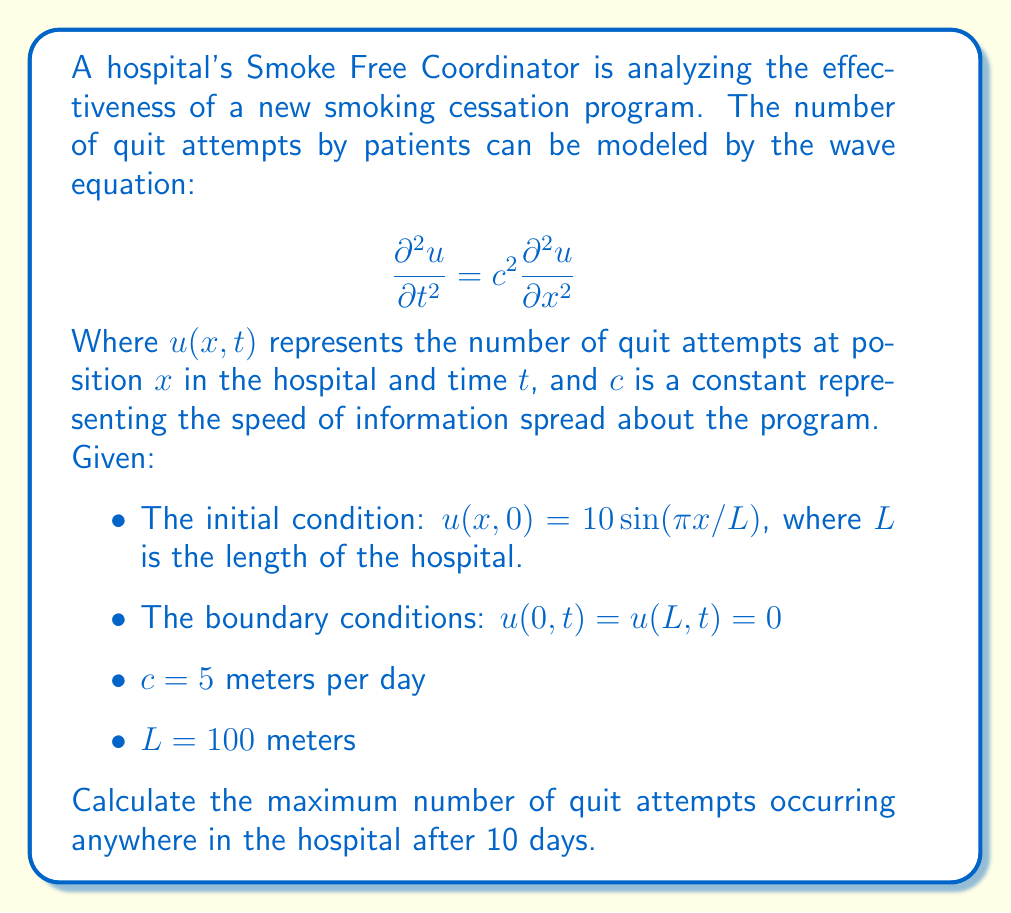Could you help me with this problem? To solve this problem, we need to use the general solution of the wave equation with the given initial and boundary conditions. The solution takes the form:

$$u(x,t) = \sum_{n=1}^{\infty} [A_n \cos(n\pi ct/L) + B_n \sin(n\pi ct/L)] \sin(n\pi x/L)$$

Given the initial condition $u(x,0) = 10 \sin(\pi x/L)$, we can determine that only the first term of the series (n=1) is non-zero, and $A_1 = 10$, $B_1 = 0$. Thus, our solution simplifies to:

$$u(x,t) = 10 \cos(\pi ct/L) \sin(\pi x/L)$$

To find the maximum number of quit attempts after 10 days, we need to:

1. Substitute the given values:
   $c = 5$ m/day
   $L = 100$ m
   $t = 10$ days

2. Calculate $\pi ct/L$:
   $$\frac{\pi ct}{L} = \frac{\pi \cdot 5 \cdot 10}{100} = \frac{\pi}{2}$$

3. Evaluate $\cos(\pi ct/L)$:
   $$\cos(\pi/2) = 0$$

4. The complete solution becomes:
   $$u(x,10) = 10 \cdot 0 \cdot \sin(\pi x/L) = 0$$

This means that after exactly 10 days, the number of quit attempts will be zero throughout the hospital. However, this is just one point in a continuous oscillation.

To find the maximum number of quit attempts, we need to consider the amplitude of the oscillation, which is 10 (the coefficient in front of the cosine term).

Therefore, the maximum number of quit attempts occurring anywhere in the hospital at any time (including but not limited to 10 days) is 10.
Answer: The maximum number of quit attempts occurring anywhere in the hospital is 10. 